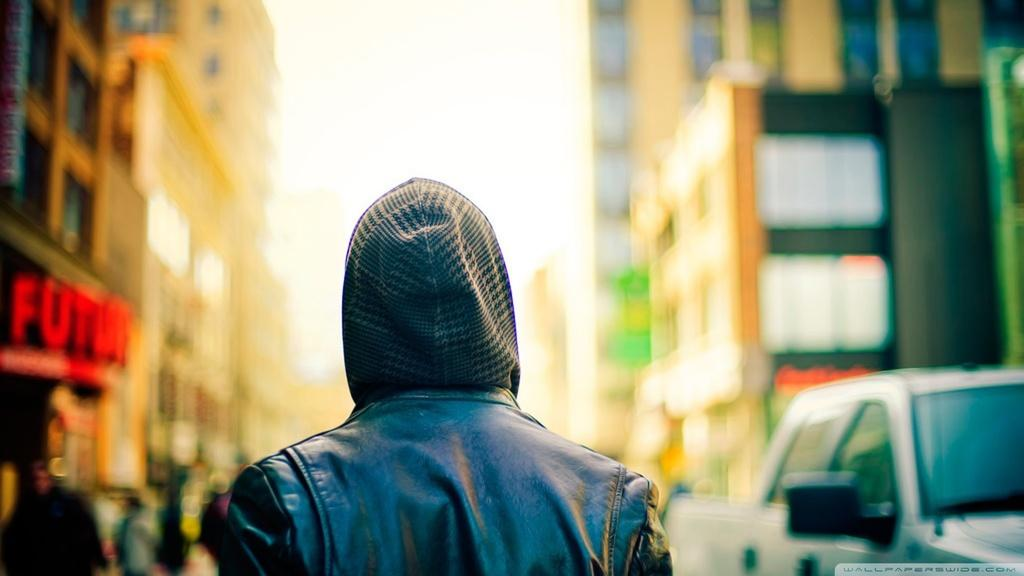What can be seen in the image that represents a large group of people? There is a crowd in the image. What else is visible on the ground in the image? Vehicles are present on the road in the image. What type of structure can be seen in the image? There is at least one building in the image. What objects are visible in the image that might be used for displaying information or advertisements? Boards are visible in the image. What part of the natural environment is visible in the image? The sky is visible in the image. Can you determine the time of day based on the image? The image appears to be taken during the day. What type of brass instrument is being played by the pig in the image? There is no brass instrument or pig present in the image. How many earthworms can be seen crawling on the boards in the image? There are no earthworms visible in the image. 